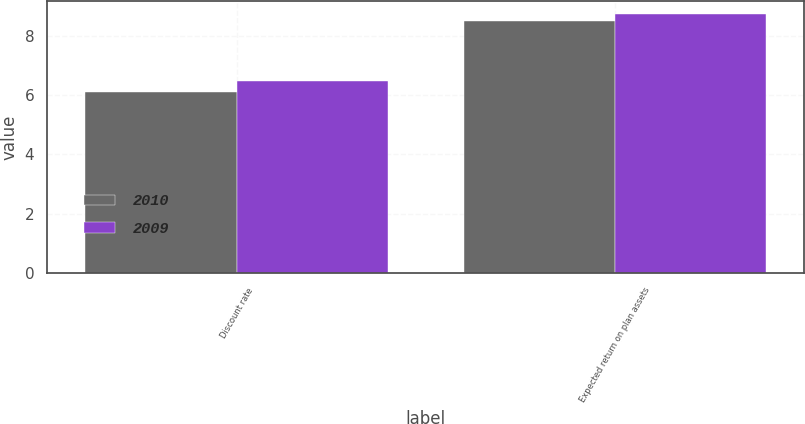<chart> <loc_0><loc_0><loc_500><loc_500><stacked_bar_chart><ecel><fcel>Discount rate<fcel>Expected return on plan assets<nl><fcel>2010<fcel>6.1<fcel>8.5<nl><fcel>2009<fcel>6.5<fcel>8.75<nl></chart> 